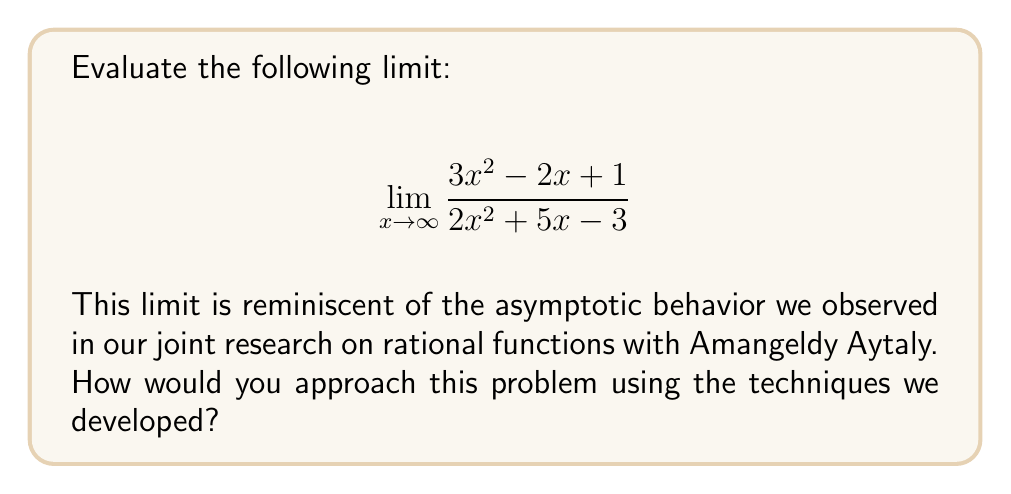Provide a solution to this math problem. Let's approach this step-by-step:

1) First, we recognize that this is a rational function where both the numerator and denominator are quadratic polynomials.

2) To evaluate the limit as $x$ approaches infinity, we need to compare the highest degree terms in the numerator and denominator.

3) In both the numerator and denominator, the highest degree term is $x^2$.

4) We can factor out $x^2$ from both the numerator and denominator:

   $$\lim_{x \to \infty} \frac{x^2(3 - \frac{2}{x} + \frac{1}{x^2})}{x^2(2 + \frac{5}{x} - \frac{3}{x^2})}$$

5) Now, as $x$ approaches infinity, the terms $\frac{2}{x}$, $\frac{1}{x^2}$, $\frac{5}{x}$, and $\frac{3}{x^2}$ all approach 0.

6) Therefore, the limit simplifies to:

   $$\lim_{x \to \infty} \frac{3}{2}$$

7) This is because the $x^2$ terms cancel out, and we're left with the ratio of the coefficients of the highest degree terms.

This method aligns with the techniques we developed with Amangeldy Aytaly, focusing on the behavior of rational functions as the variable approaches infinity.
Answer: $\frac{3}{2}$ 